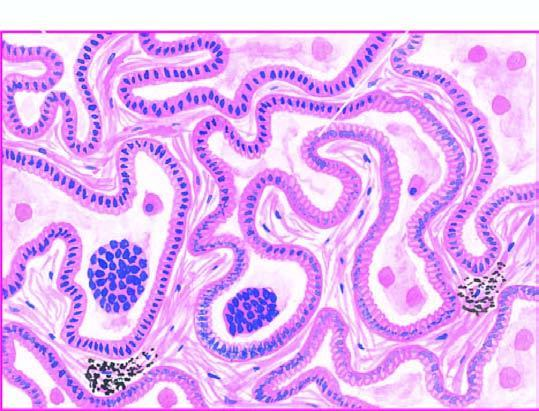what are the alveolar walls lined by?
Answer the question using a single word or phrase. Cuboidal to tall columnar and mucin-secreting tumour cells with papillary growth pattern 